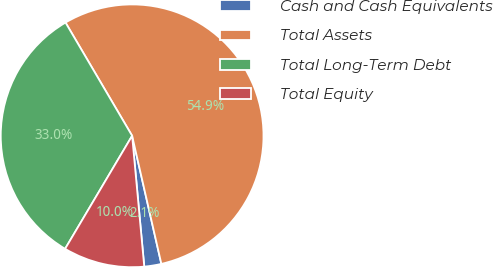Convert chart to OTSL. <chart><loc_0><loc_0><loc_500><loc_500><pie_chart><fcel>Cash and Cash Equivalents<fcel>Total Assets<fcel>Total Long-Term Debt<fcel>Total Equity<nl><fcel>2.1%<fcel>54.89%<fcel>33.02%<fcel>9.99%<nl></chart> 